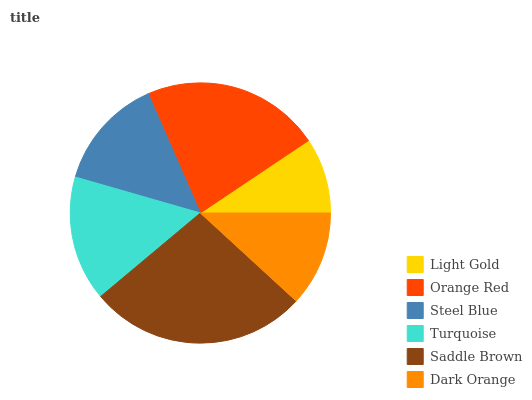Is Light Gold the minimum?
Answer yes or no. Yes. Is Saddle Brown the maximum?
Answer yes or no. Yes. Is Orange Red the minimum?
Answer yes or no. No. Is Orange Red the maximum?
Answer yes or no. No. Is Orange Red greater than Light Gold?
Answer yes or no. Yes. Is Light Gold less than Orange Red?
Answer yes or no. Yes. Is Light Gold greater than Orange Red?
Answer yes or no. No. Is Orange Red less than Light Gold?
Answer yes or no. No. Is Turquoise the high median?
Answer yes or no. Yes. Is Steel Blue the low median?
Answer yes or no. Yes. Is Dark Orange the high median?
Answer yes or no. No. Is Dark Orange the low median?
Answer yes or no. No. 